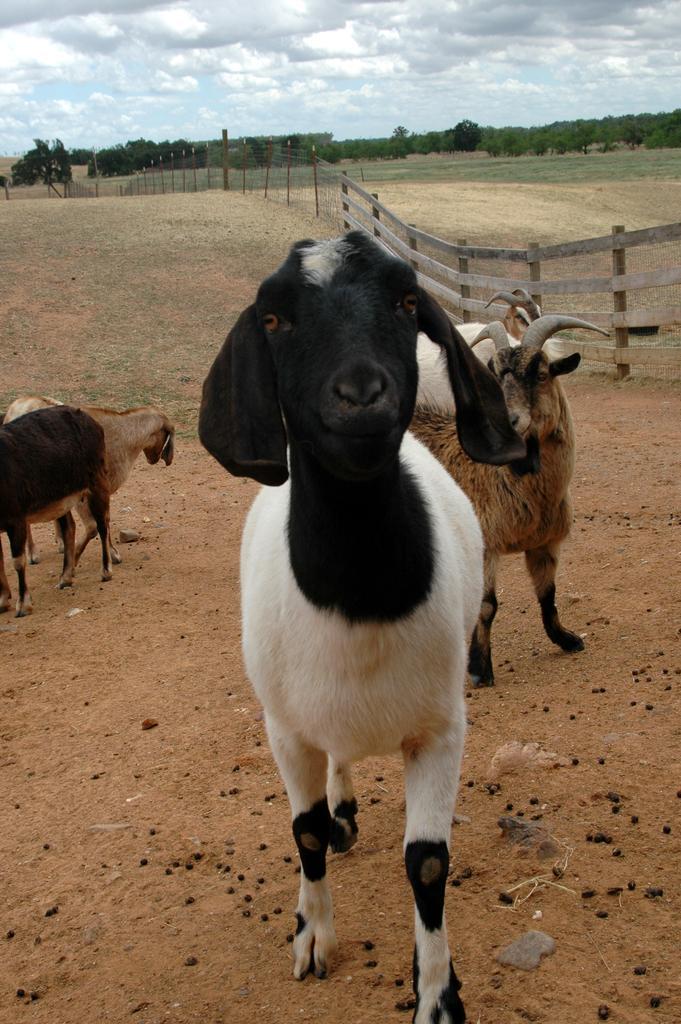In one or two sentences, can you explain what this image depicts? In this image we can see many trees. There is a cloudy sky in the image. There is a fencing in the image. There are few animals in the image. There is a grassy land in the image. 